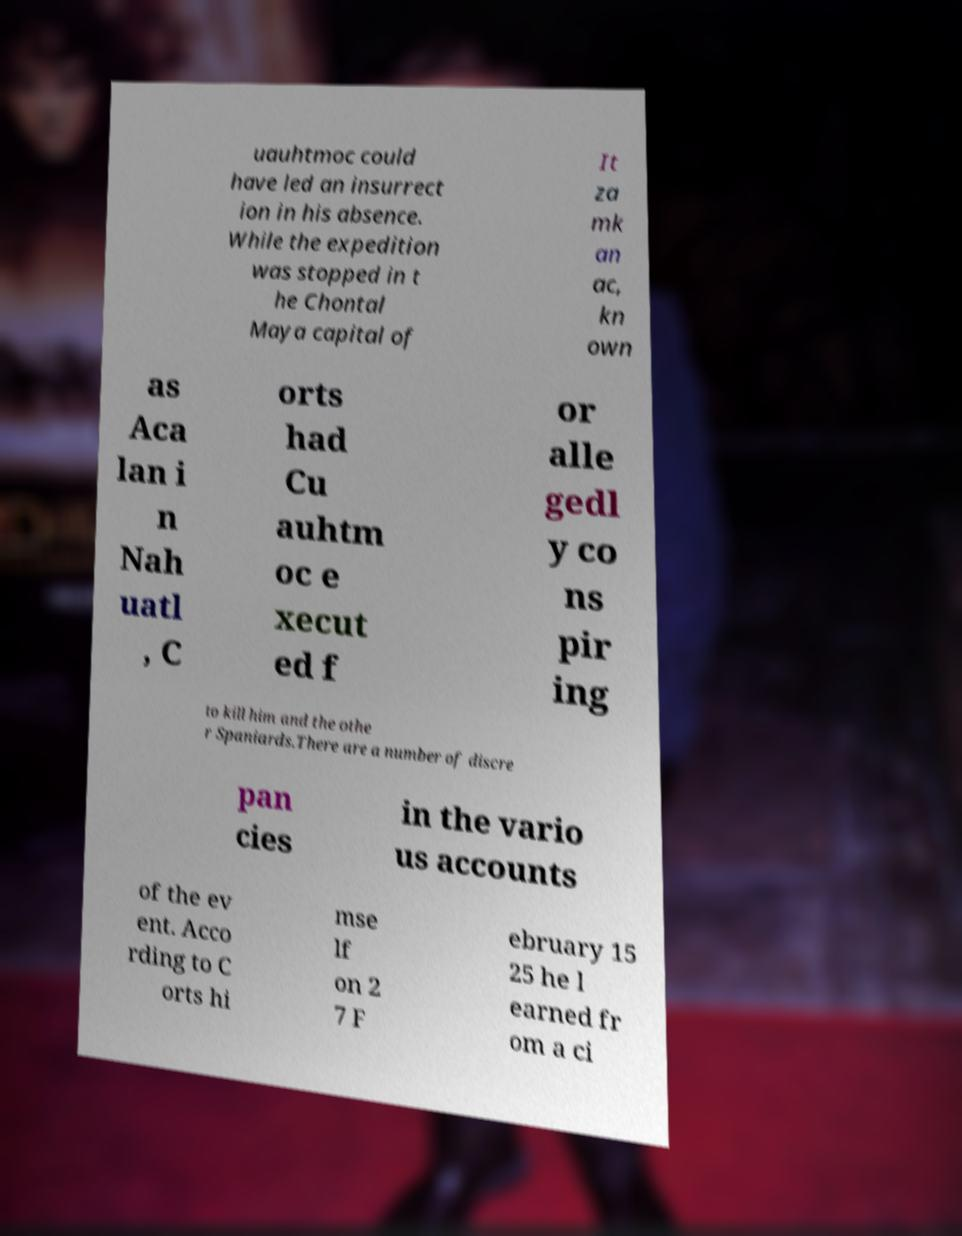Could you assist in decoding the text presented in this image and type it out clearly? uauhtmoc could have led an insurrect ion in his absence. While the expedition was stopped in t he Chontal Maya capital of It za mk an ac, kn own as Aca lan i n Nah uatl , C orts had Cu auhtm oc e xecut ed f or alle gedl y co ns pir ing to kill him and the othe r Spaniards.There are a number of discre pan cies in the vario us accounts of the ev ent. Acco rding to C orts hi mse lf on 2 7 F ebruary 15 25 he l earned fr om a ci 